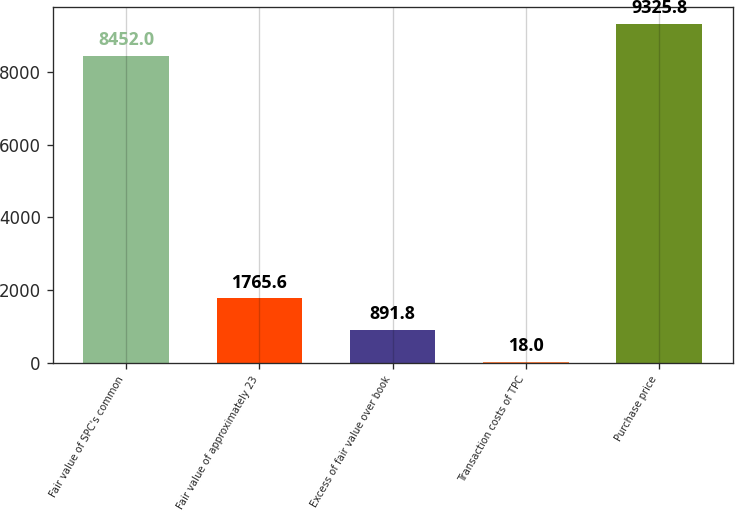Convert chart. <chart><loc_0><loc_0><loc_500><loc_500><bar_chart><fcel>Fair value of SPC's common<fcel>Fair value of approximately 23<fcel>Excess of fair value over book<fcel>Transaction costs of TPC<fcel>Purchase price<nl><fcel>8452<fcel>1765.6<fcel>891.8<fcel>18<fcel>9325.8<nl></chart> 